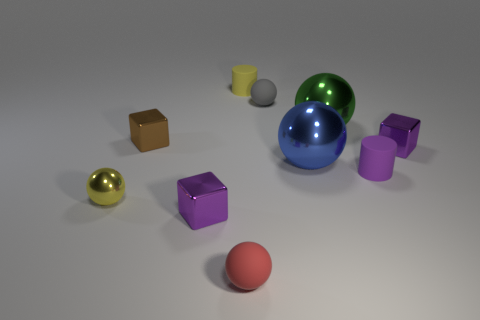What number of spheres are either brown metal objects or tiny yellow things?
Ensure brevity in your answer.  1. There is a tiny sphere that is behind the tiny brown metal block; what is it made of?
Give a very brief answer. Rubber. Is the number of small yellow balls less than the number of tiny cylinders?
Keep it short and to the point. Yes. What is the size of the matte thing that is both in front of the tiny yellow matte thing and on the left side of the tiny gray rubber object?
Make the answer very short. Small. There is a matte sphere that is to the left of the tiny yellow thing that is behind the matte ball behind the brown object; how big is it?
Make the answer very short. Small. How many other things are the same color as the tiny metal sphere?
Offer a terse response. 1. There is a tiny rubber cylinder that is in front of the tiny gray rubber ball; is it the same color as the tiny shiny ball?
Make the answer very short. No. How many objects are either tiny purple things or small metal objects?
Your answer should be compact. 5. The metal ball to the left of the big blue ball is what color?
Ensure brevity in your answer.  Yellow. Are there fewer tiny brown shiny objects in front of the tiny red thing than purple metal things?
Make the answer very short. Yes. 